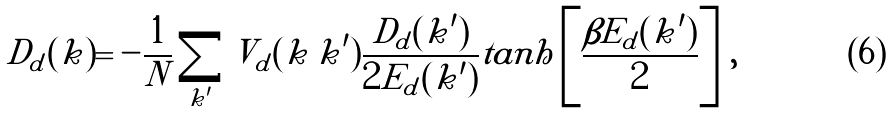<formula> <loc_0><loc_0><loc_500><loc_500>D _ { d } ( { k } ) = - \frac { 1 } { N } \sum _ { { k ^ { \prime } } } V _ { d } ( { k \, k ^ { \prime } } ) \frac { D _ { d } ( { k ^ { \prime } } ) } { 2 E _ { d } ( { k ^ { \prime } } ) } t a n h \left [ \frac { \beta E _ { d } ( { k ^ { \prime } } ) } { 2 } \right ] \, ,</formula> 